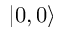<formula> <loc_0><loc_0><loc_500><loc_500>| 0 , 0 \rangle</formula> 